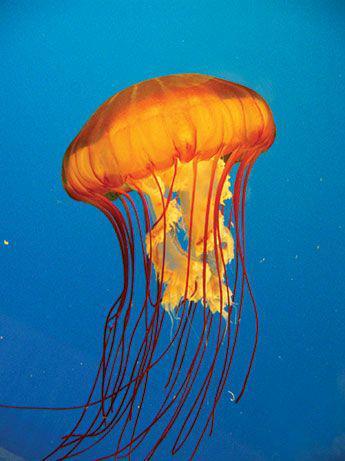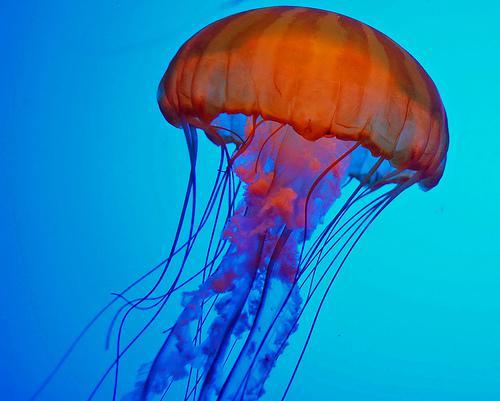The first image is the image on the left, the second image is the image on the right. Analyze the images presented: Is the assertion "At least one image shows one orange jellyfish with frilly tendrils hanging down between stringlike ones." valid? Answer yes or no. Yes. The first image is the image on the left, the second image is the image on the right. For the images shown, is this caption "The jellyfish's long tendrils flow beneath them." true? Answer yes or no. Yes. 